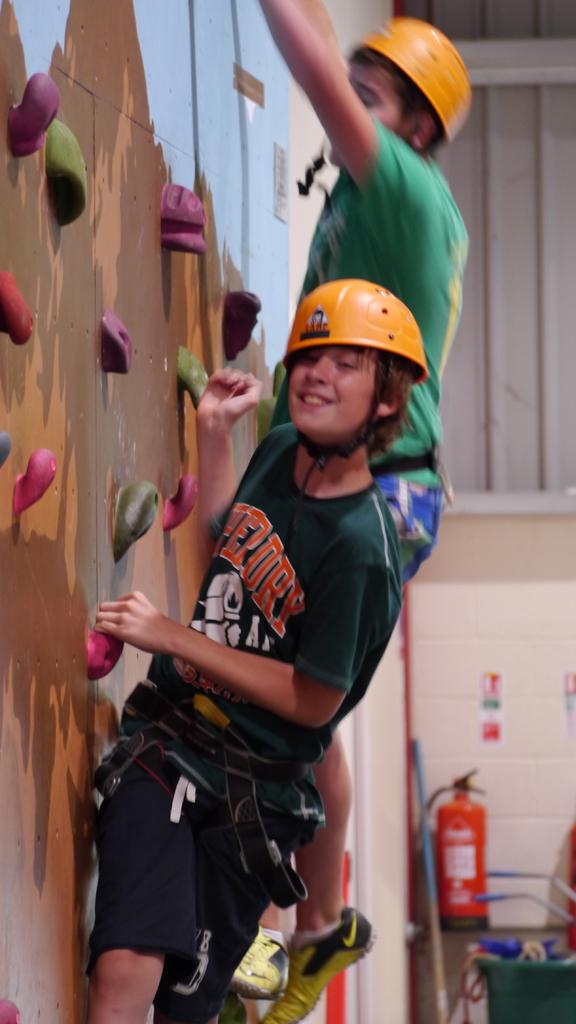What is the person in the image doing? There is a person climbing a wall in the image. Can you describe any objects or tools near the person? There is a fire extinguisher beside the person. What type of whip is the person using to climb the wall in the image? There is no whip present in the image; the person is climbing the wall without any visible tools or equipment. 